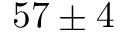Convert formula to latex. <formula><loc_0><loc_0><loc_500><loc_500>5 7 \pm 4</formula> 